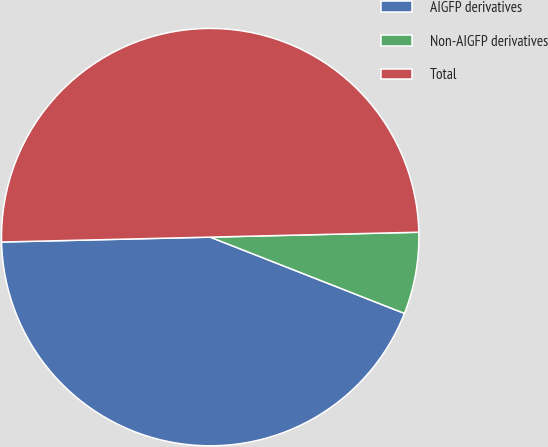<chart> <loc_0><loc_0><loc_500><loc_500><pie_chart><fcel>AIGFP derivatives<fcel>Non-AIGFP derivatives<fcel>Total<nl><fcel>43.67%<fcel>6.33%<fcel>50.0%<nl></chart> 